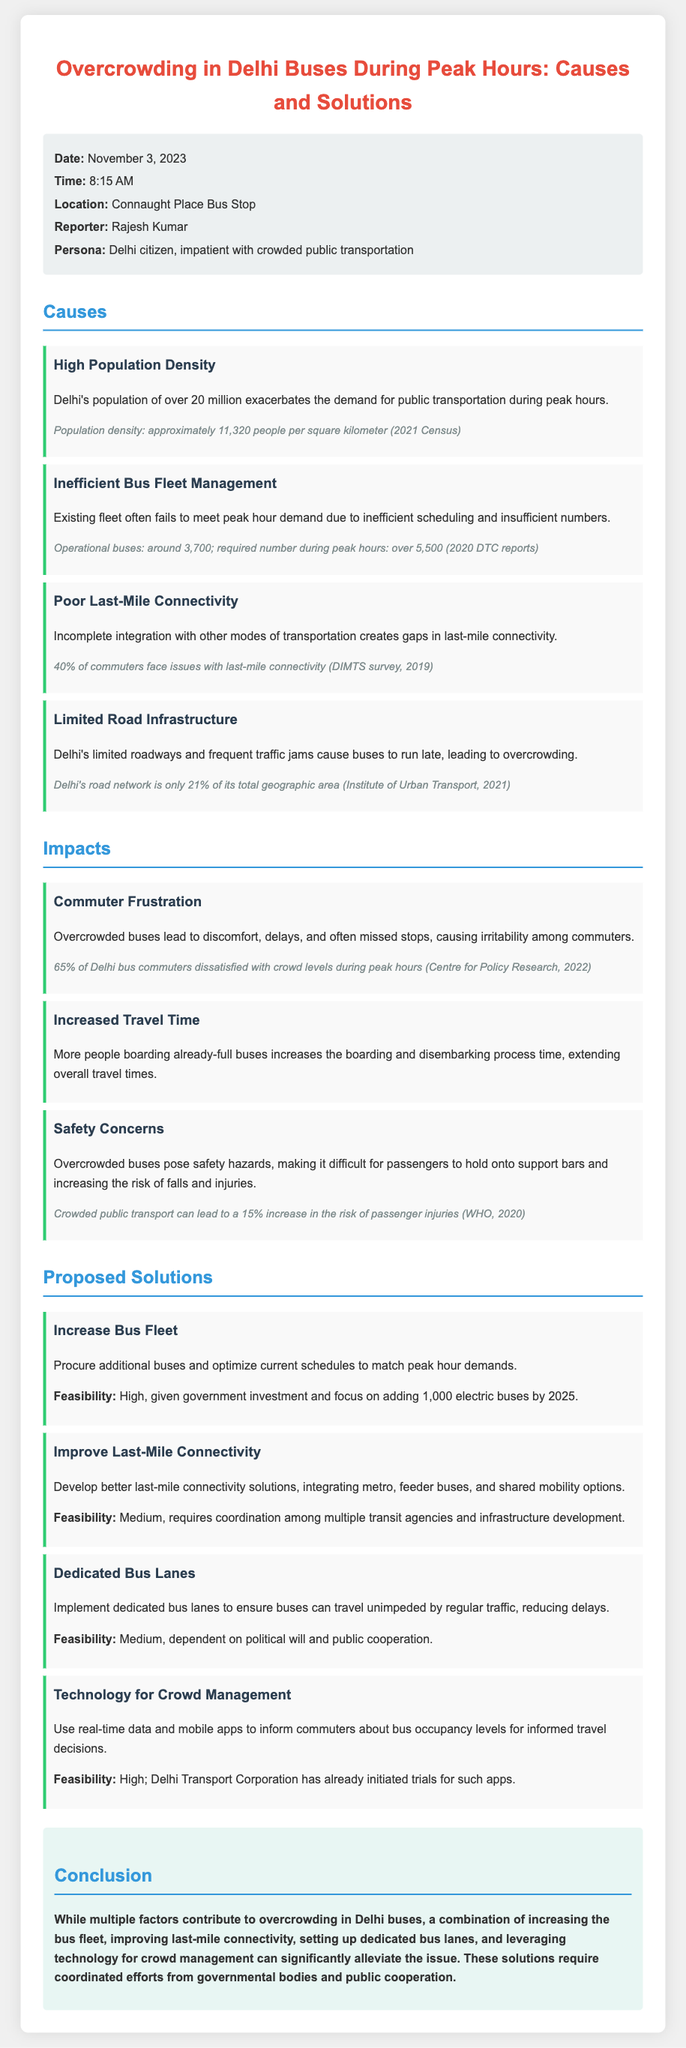What is the date of the incident report? The report states that the incident occurred on November 3, 2023.
Answer: November 3, 2023 What is the time of the incident? The report mentions the incident took place at 8:15 AM.
Answer: 8:15 AM How many operational buses are there in the fleet? The document mentions that there are around 3,700 operational buses.
Answer: 3,700 What percentage of commuters face issues with last-mile connectivity? The report indicates that 40% of commuters have issues with last-mile connectivity.
Answer: 40% What is one proposed solution to overcrowding in Delhi buses? The document suggests increasing the bus fleet as a solution.
Answer: Increase Bus Fleet What is the population density of Delhi according to the 2021 Census? The document states that the population density is approximately 11,320 people per square kilometer.
Answer: 11,320 people per square kilometer What is the feasibility of implementing dedicated bus lanes? The report states that the feasibility is medium, dependent on political will and public cooperation.
Answer: Medium What sector experiences delays due to overcrowded buses according to the report? The report mentions that commuter frustration is a significant impact due to delays.
Answer: Commuter Frustration What did the survey by the Centre for Policy Research reveal about commuter satisfaction? The survey revealed that 65% of Delhi bus commuters are dissatisfied with crowd levels during peak hours.
Answer: 65% 